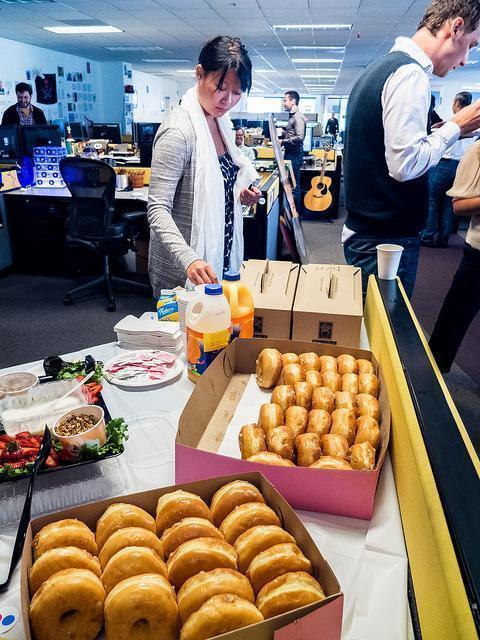What setting does this seem to be?
Choose the right answer and clarify with the format: 'Answer: answer
Rationale: rationale.'
Options: School, office, library, home. Answer: office.
Rationale: The donuts are laid out in an office. 